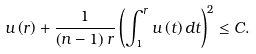Convert formula to latex. <formula><loc_0><loc_0><loc_500><loc_500>u \left ( r \right ) + \frac { 1 } { \left ( n - 1 \right ) r } \left ( \int _ { 1 } ^ { r } u \left ( t \right ) d t \right ) ^ { 2 } \leq C .</formula> 